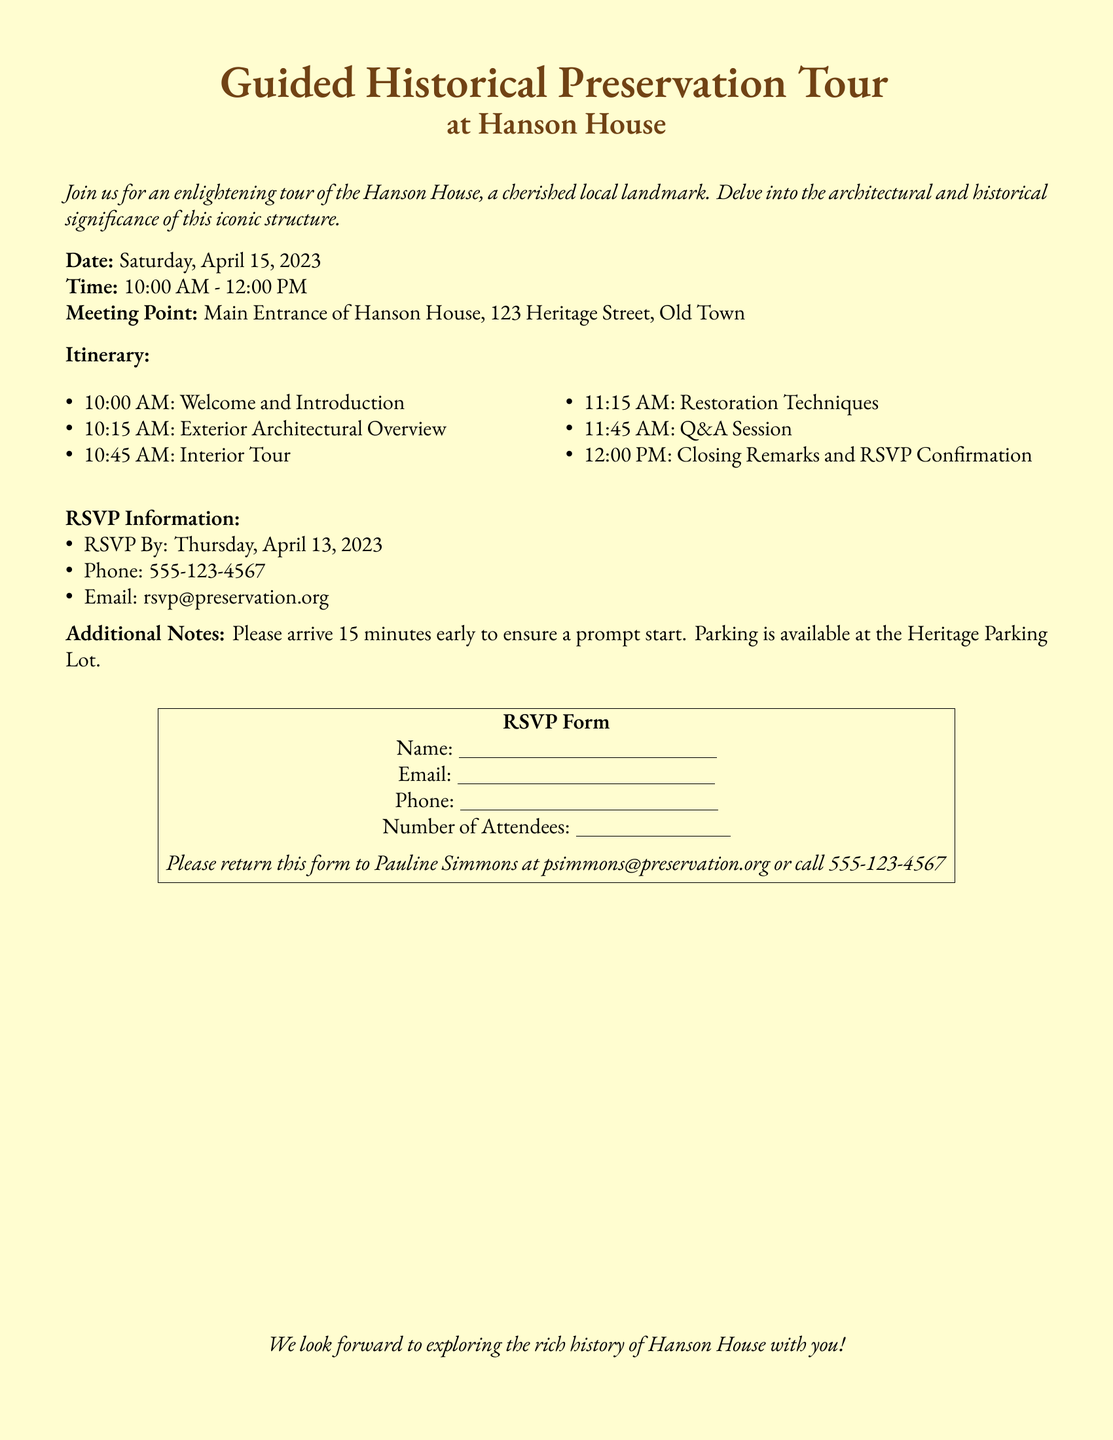what is the date of the tour? The date of the tour is mentioned clearly in the document.
Answer: Saturday, April 15, 2023 what time does the tour start? The starting time of the tour is listed in the itinerary section.
Answer: 10:00 AM where is the meeting point for the tour? The meeting point is specified in the document's details.
Answer: Main Entrance of Hanson House, 123 Heritage Street, Old Town how many sessions are there in the itinerary? The itinerary lists the different segments of the tour which can be counted.
Answer: 6 when is the RSVPs deadline? The RSVP information states the deadline for RSVPs.
Answer: Thursday, April 13, 2023 what type of session follows the interior tour? This requires understanding the sequence of events in the itinerary.
Answer: Restoration Techniques who should the RSVP form be returned to? The additional notes specify the contact person for returning the form.
Answer: Pauline Simmons is parking available at the tour location? This is addressed in the additional notes section of the document.
Answer: Yes what is the email address for RSVPs? The document provides an email address for RSVP inquiries.
Answer: rsvp@preservation.org 